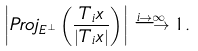<formula> <loc_0><loc_0><loc_500><loc_500>\left | P r o j _ { E ^ { \perp } } \left ( \frac { T _ { i } x } { | T _ { i } x | } \right ) \right | \stackrel { i \rightarrow \infty } \longrightarrow 1 .</formula> 